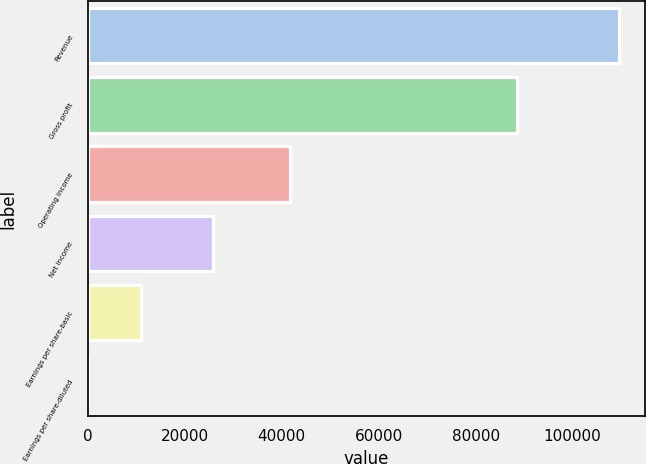Convert chart to OTSL. <chart><loc_0><loc_0><loc_500><loc_500><bar_chart><fcel>Revenue<fcel>Gross profit<fcel>Operating income<fcel>Net income<fcel>Earnings per share-basic<fcel>Earnings per share-diluted<nl><fcel>109545<fcel>88638<fcel>41801<fcel>25854<fcel>10954.8<fcel>0.32<nl></chart> 